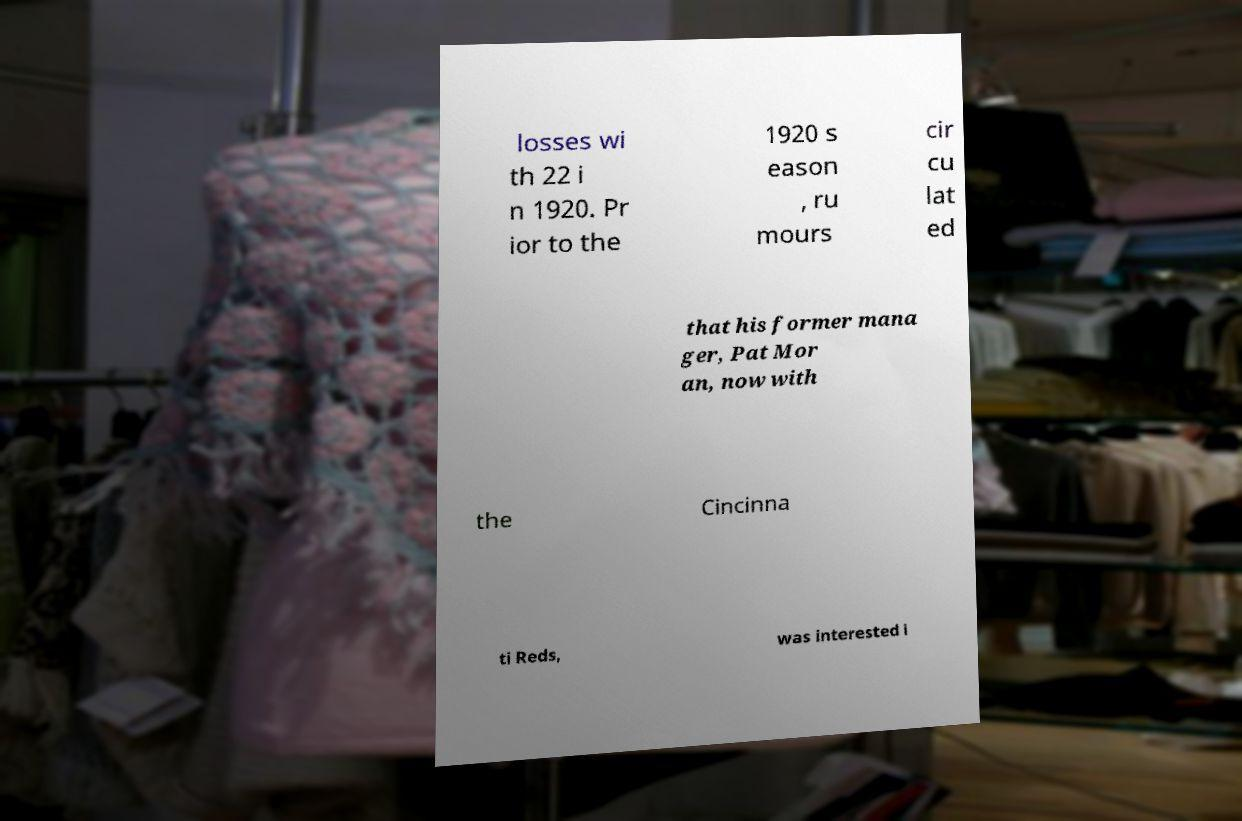Could you assist in decoding the text presented in this image and type it out clearly? losses wi th 22 i n 1920. Pr ior to the 1920 s eason , ru mours cir cu lat ed that his former mana ger, Pat Mor an, now with the Cincinna ti Reds, was interested i 